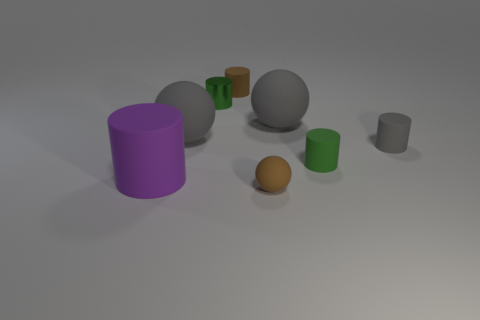Subtract all yellow balls. Subtract all brown cylinders. How many balls are left? 3 Subtract all cyan balls. How many red cylinders are left? 0 Add 8 blues. How many things exist? 0 Subtract all brown things. Subtract all small gray cylinders. How many objects are left? 5 Add 1 green objects. How many green objects are left? 3 Add 6 tiny shiny cylinders. How many tiny shiny cylinders exist? 7 Add 1 big cubes. How many objects exist? 9 Subtract all green cylinders. How many cylinders are left? 3 Subtract all big balls. How many balls are left? 1 Subtract 0 blue balls. How many objects are left? 8 